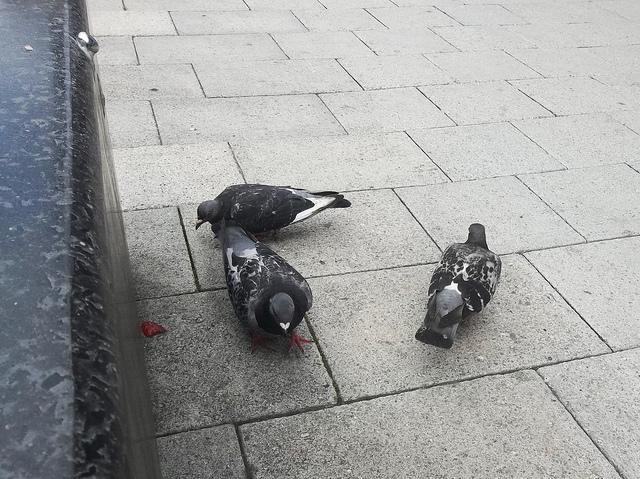What type of bird is in the photo?
Write a very short answer. Pigeon. Are these pigeons in anyone's way?
Be succinct. No. What color are the birds' feet?
Short answer required. Red. 